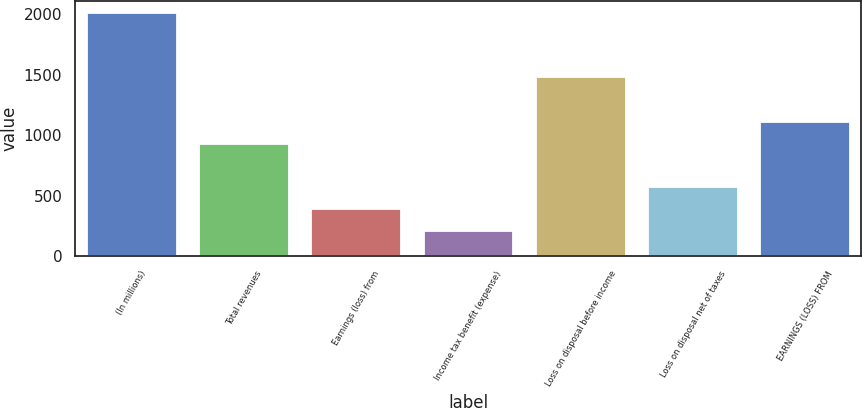<chart> <loc_0><loc_0><loc_500><loc_500><bar_chart><fcel>(In millions)<fcel>Total revenues<fcel>Earnings (loss) from<fcel>Income tax benefit (expense)<fcel>Loss on disposal before income<fcel>Loss on disposal net of taxes<fcel>EARNINGS (LOSS) FROM<nl><fcel>2008<fcel>930.4<fcel>391.6<fcel>212<fcel>1479<fcel>571.2<fcel>1110<nl></chart> 